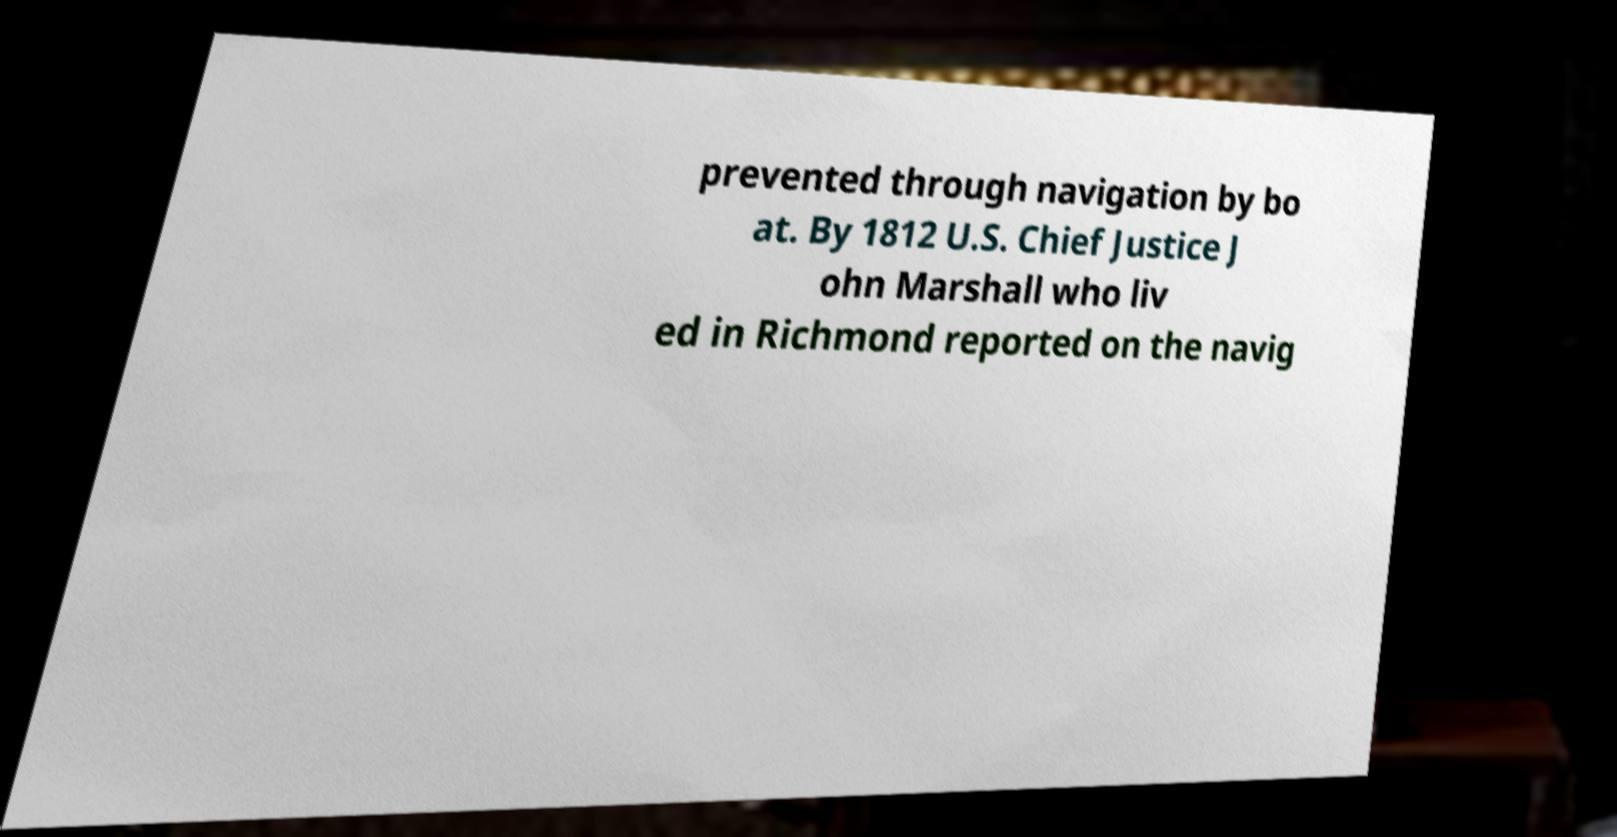What messages or text are displayed in this image? I need them in a readable, typed format. prevented through navigation by bo at. By 1812 U.S. Chief Justice J ohn Marshall who liv ed in Richmond reported on the navig 